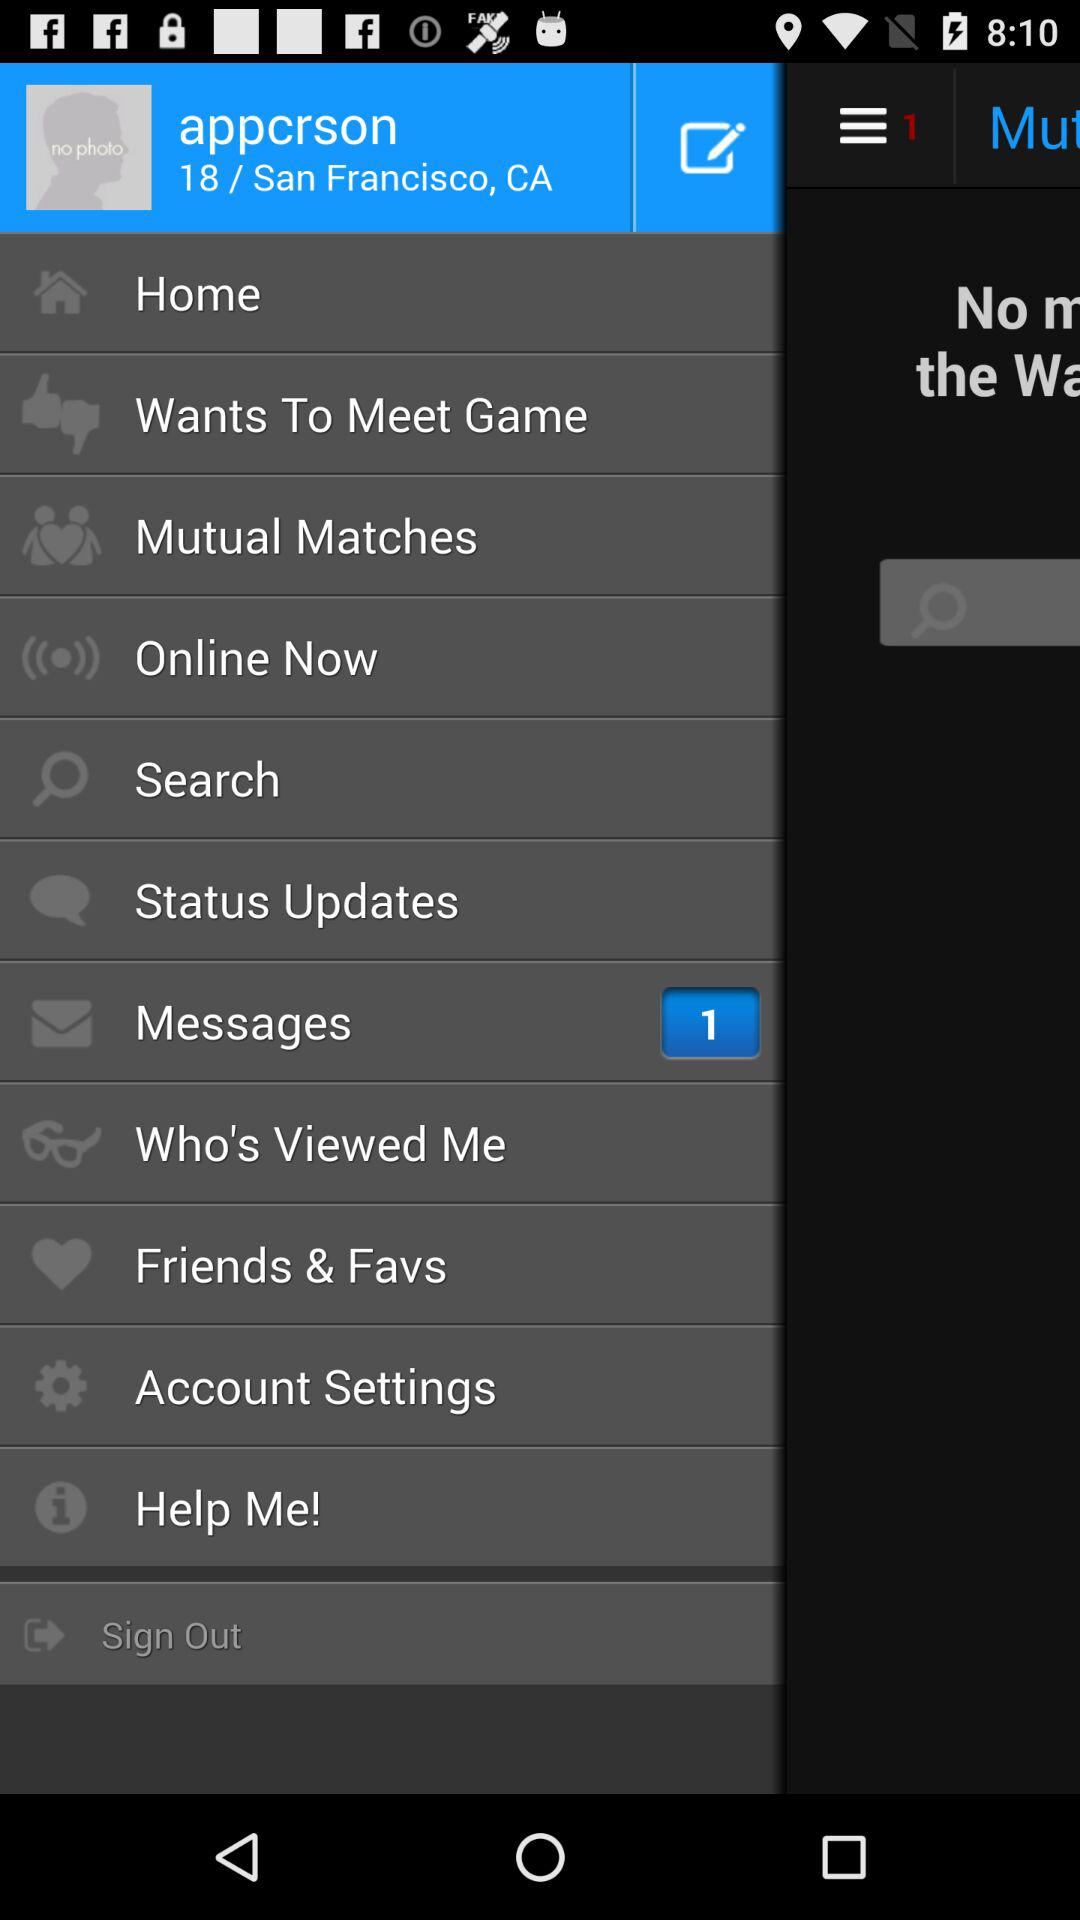What is the shown location? The shown location is San Francisco, CA. 